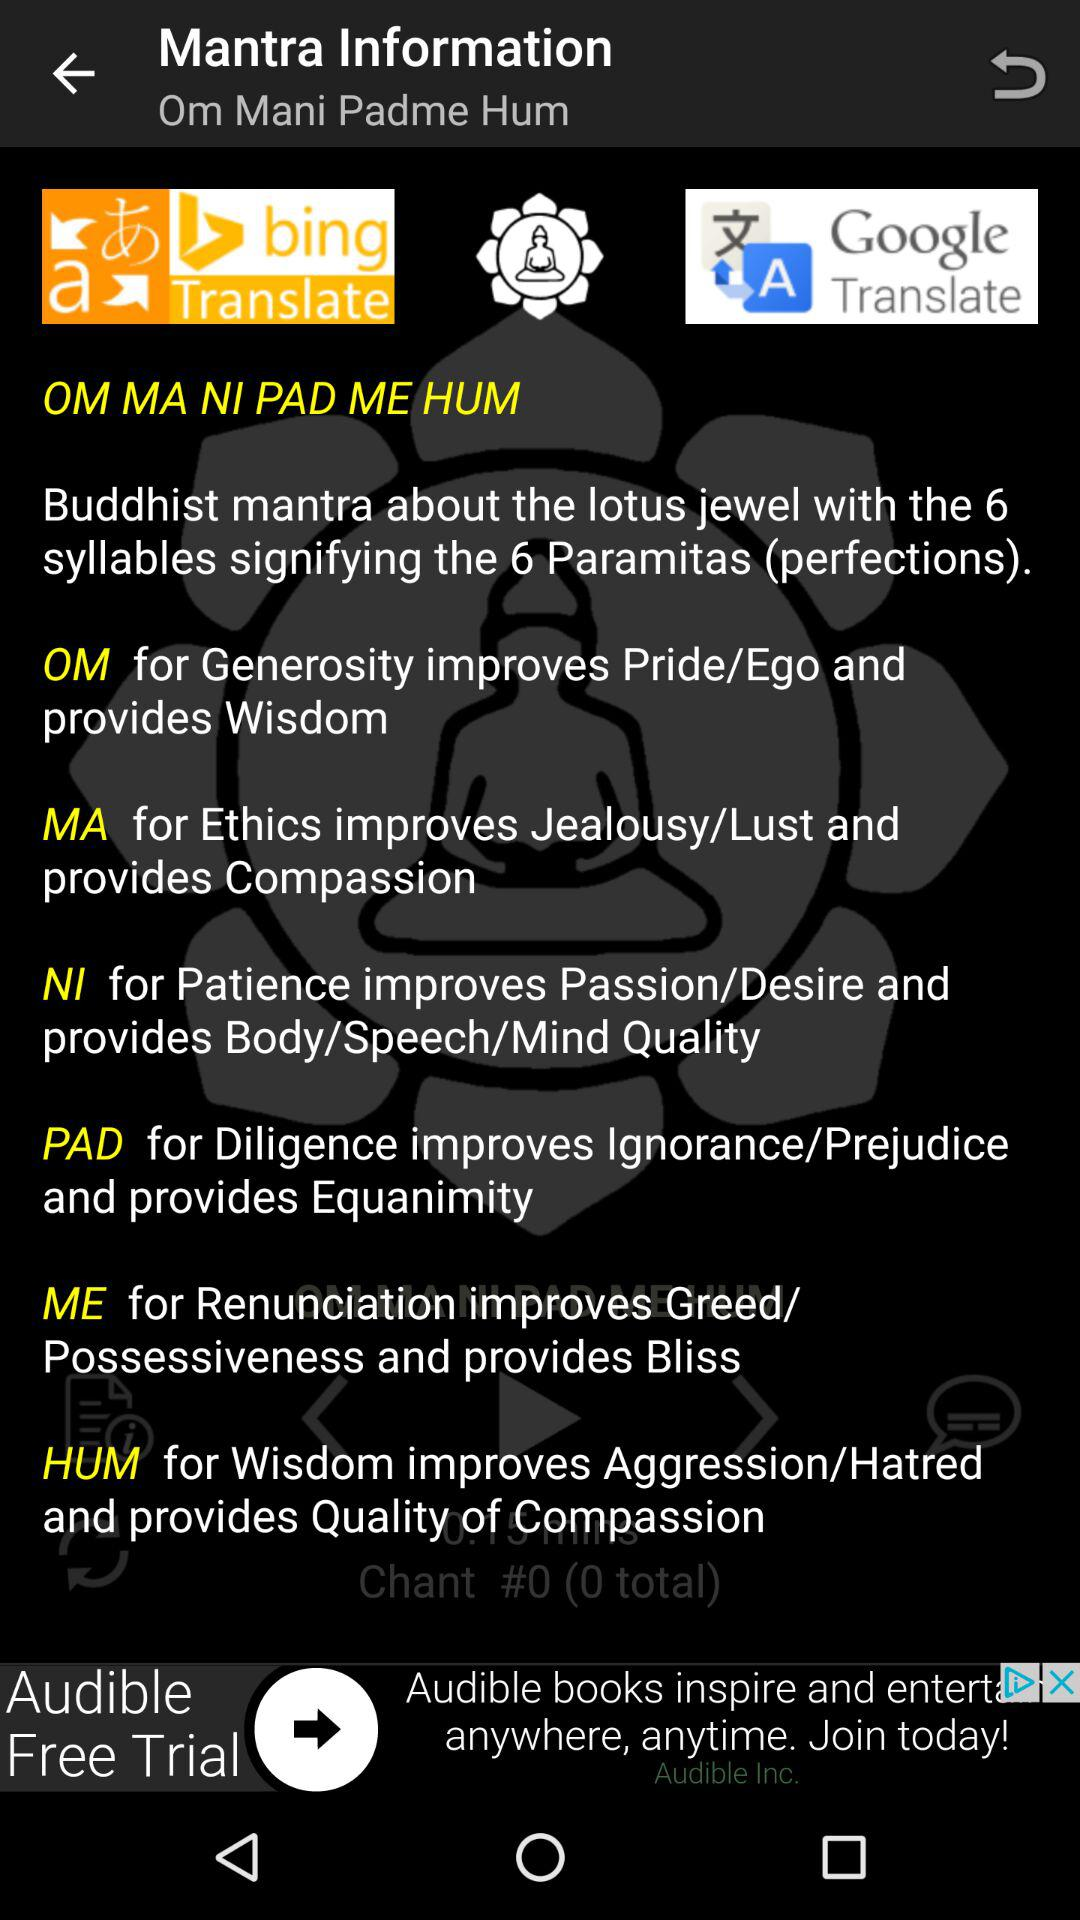How many perfects are there?
Answer the question using a single word or phrase. 6 